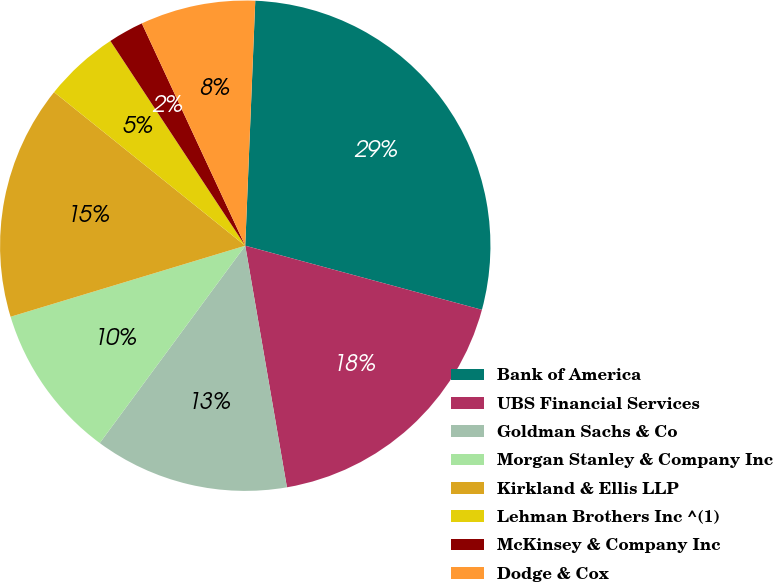Convert chart. <chart><loc_0><loc_0><loc_500><loc_500><pie_chart><fcel>Bank of America<fcel>UBS Financial Services<fcel>Goldman Sachs & Co<fcel>Morgan Stanley & Company Inc<fcel>Kirkland & Ellis LLP<fcel>Lehman Brothers Inc ^(1)<fcel>McKinsey & Company Inc<fcel>Dodge & Cox<nl><fcel>28.56%<fcel>18.07%<fcel>12.83%<fcel>10.21%<fcel>15.45%<fcel>4.96%<fcel>2.34%<fcel>7.58%<nl></chart> 